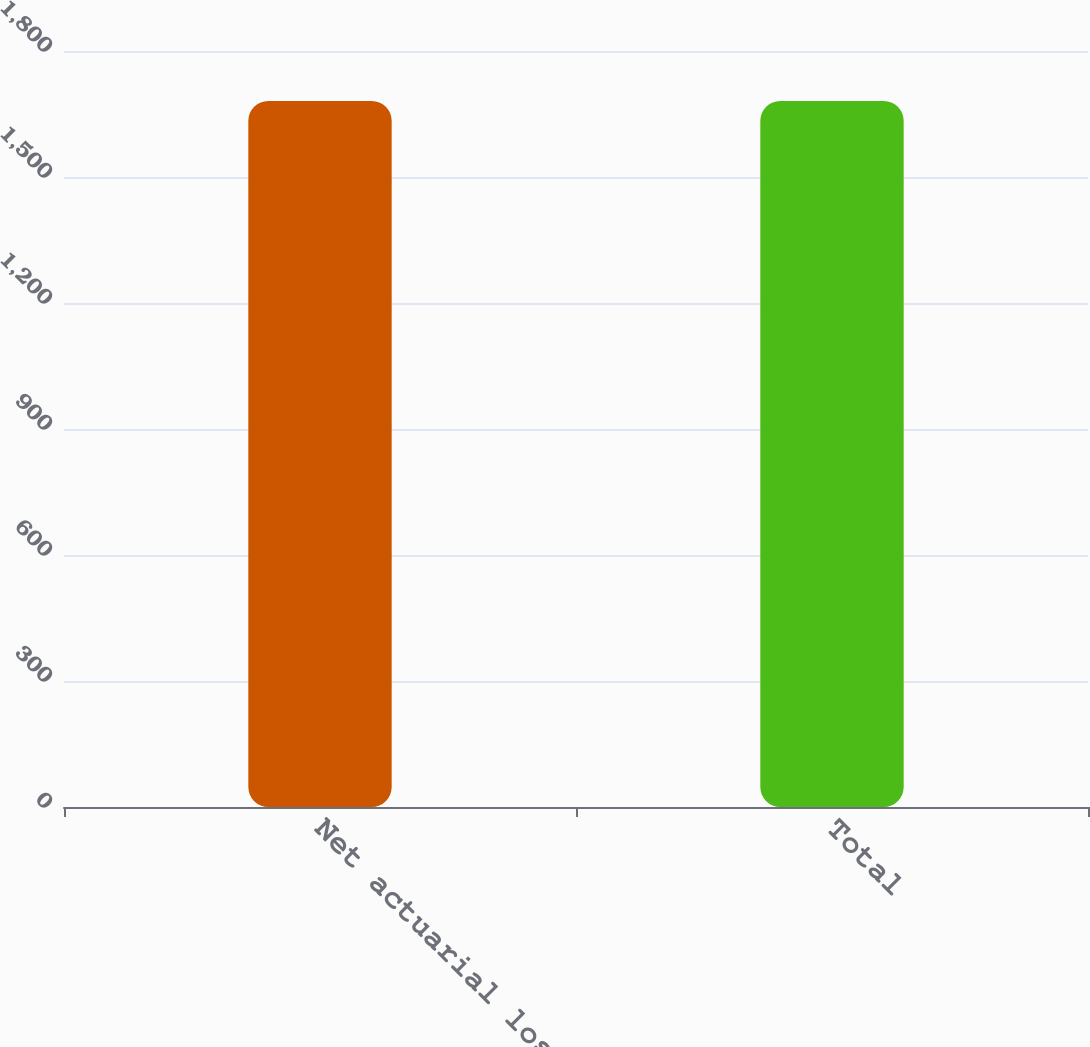Convert chart to OTSL. <chart><loc_0><loc_0><loc_500><loc_500><bar_chart><fcel>Net actuarial loss<fcel>Total<nl><fcel>1681<fcel>1681.1<nl></chart> 